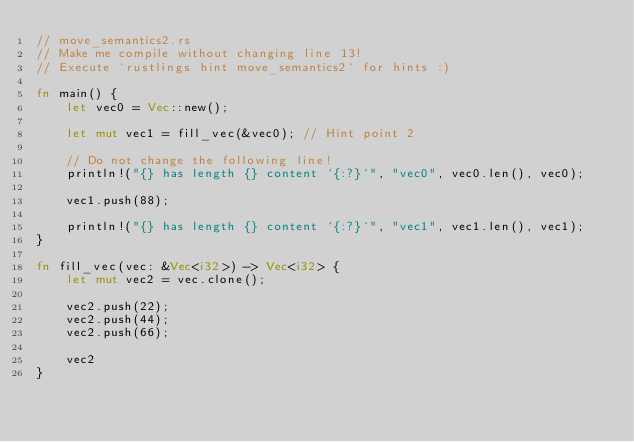<code> <loc_0><loc_0><loc_500><loc_500><_Rust_>// move_semantics2.rs
// Make me compile without changing line 13!
// Execute `rustlings hint move_semantics2` for hints :)

fn main() {
    let vec0 = Vec::new();

    let mut vec1 = fill_vec(&vec0); // Hint point 2

    // Do not change the following line!
    println!("{} has length {} content `{:?}`", "vec0", vec0.len(), vec0);

    vec1.push(88);

    println!("{} has length {} content `{:?}`", "vec1", vec1.len(), vec1);
}

fn fill_vec(vec: &Vec<i32>) -> Vec<i32> {
    let mut vec2 = vec.clone();

    vec2.push(22);
    vec2.push(44);
    vec2.push(66);

    vec2
}
</code> 